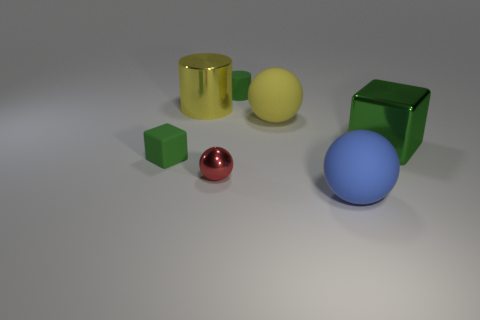Add 1 large cylinders. How many objects exist? 8 Subtract all cubes. How many objects are left? 5 Add 6 shiny cylinders. How many shiny cylinders exist? 7 Subtract 0 brown spheres. How many objects are left? 7 Subtract all big spheres. Subtract all rubber things. How many objects are left? 1 Add 2 metal cylinders. How many metal cylinders are left? 3 